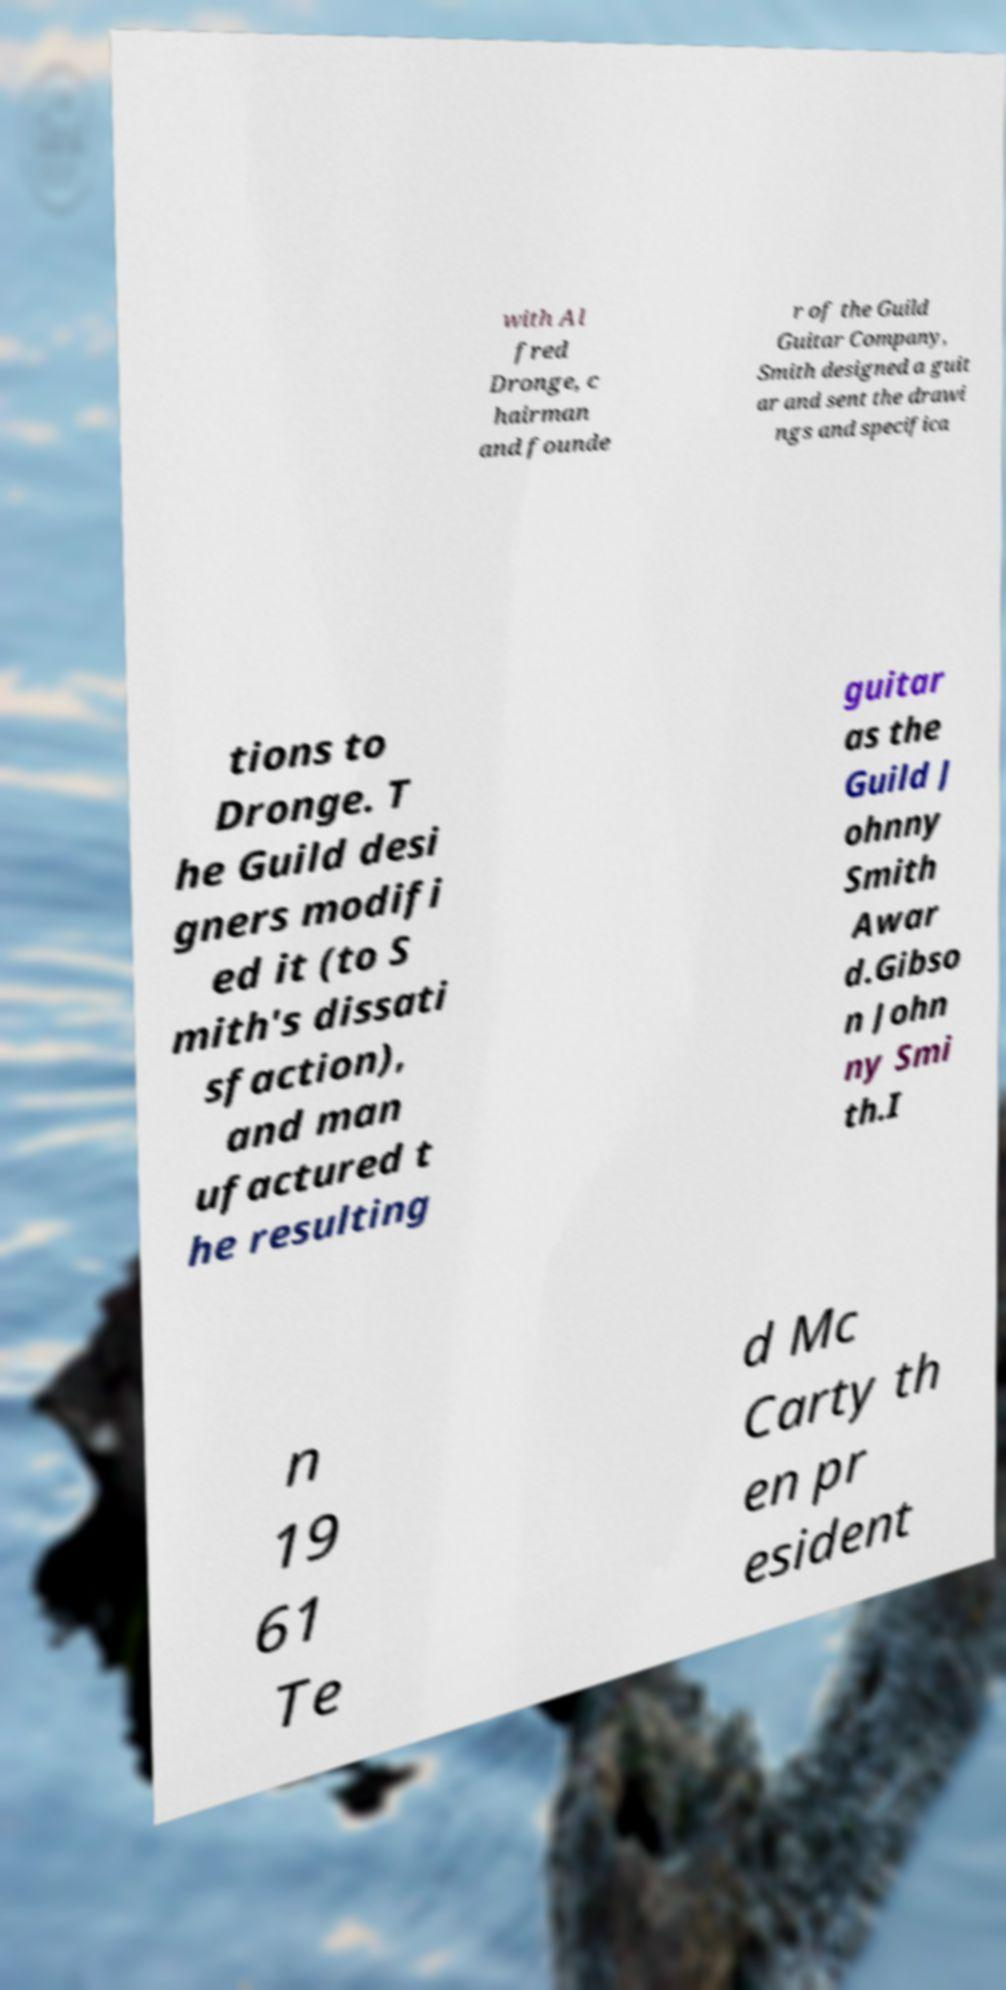Can you accurately transcribe the text from the provided image for me? with Al fred Dronge, c hairman and founde r of the Guild Guitar Company, Smith designed a guit ar and sent the drawi ngs and specifica tions to Dronge. T he Guild desi gners modifi ed it (to S mith's dissati sfaction), and man ufactured t he resulting guitar as the Guild J ohnny Smith Awar d.Gibso n John ny Smi th.I n 19 61 Te d Mc Carty th en pr esident 